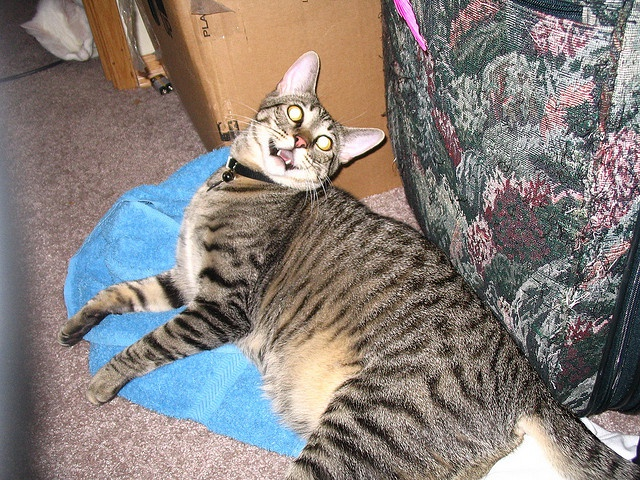Describe the objects in this image and their specific colors. I can see cat in black, gray, darkgray, and lightgray tones, suitcase in black, gray, darkgray, and lightgray tones, and cat in black, darkgray, and gray tones in this image. 